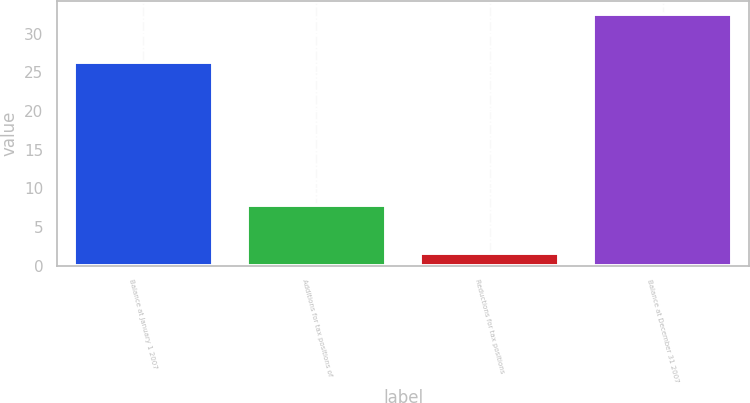Convert chart to OTSL. <chart><loc_0><loc_0><loc_500><loc_500><bar_chart><fcel>Balance at January 1 2007<fcel>Additions for tax positions of<fcel>Reductions for tax positions<fcel>Balance at December 31 2007<nl><fcel>26.3<fcel>7.9<fcel>1.6<fcel>32.6<nl></chart> 